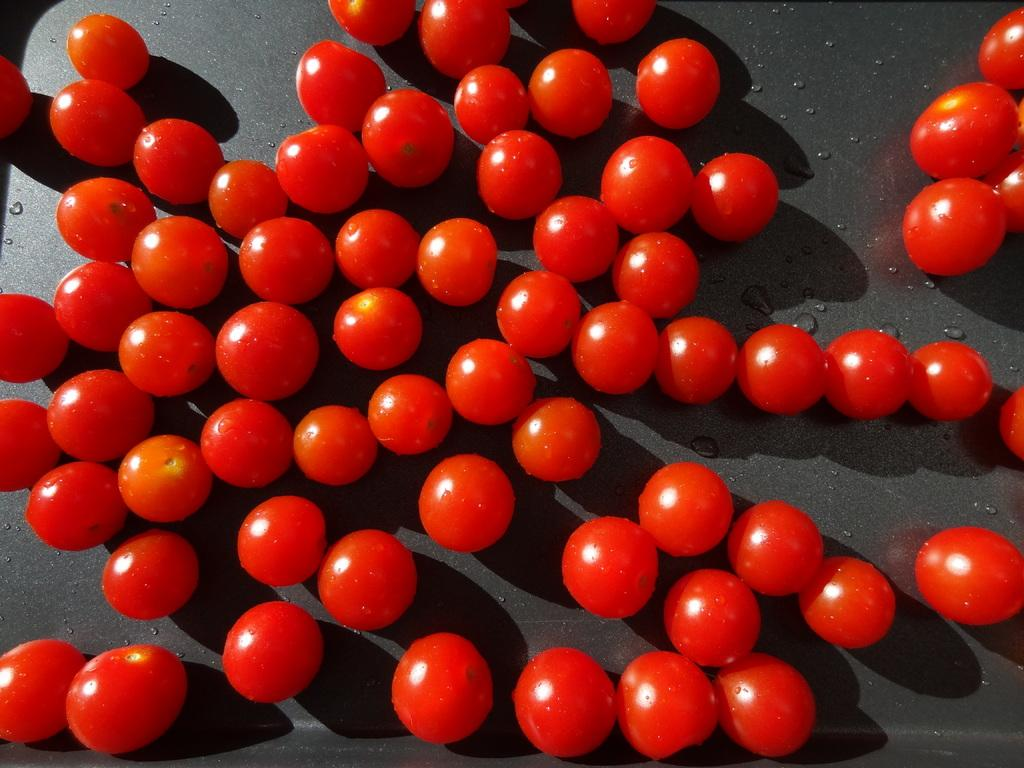What type of fruit is visible in the image? There is a group of tomatoes in the image. What else can be seen on the black surface in the image? There are water drops on a black surface in the image. Can you see any veins on the tomatoes in the image? There is no mention of veins on the tomatoes in the image, so we cannot determine their presence. --- 